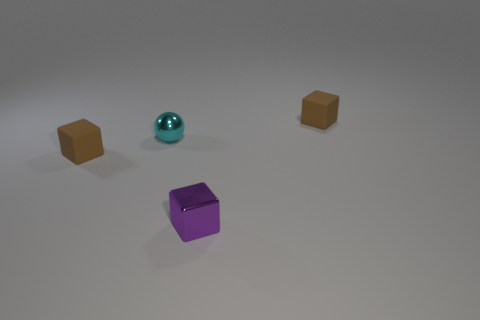There is a brown rubber object to the right of the shiny cube; does it have the same shape as the small purple object?
Offer a terse response. Yes. There is a tiny ball that is made of the same material as the purple cube; what is its color?
Give a very brief answer. Cyan. What material is the brown thing to the right of the cyan metal ball?
Keep it short and to the point. Rubber. There is a small purple shiny object; is its shape the same as the rubber thing that is in front of the tiny cyan ball?
Your answer should be compact. Yes. What is the material of the small cube that is both to the right of the cyan metallic ball and in front of the metal ball?
Offer a terse response. Metal. What is the color of the metallic cube that is the same size as the sphere?
Ensure brevity in your answer.  Purple. Is the tiny purple cube made of the same material as the cyan object that is behind the metallic block?
Offer a very short reply. Yes. What number of other things are the same size as the cyan sphere?
Make the answer very short. 3. Is there a cyan metallic sphere that is on the right side of the small block that is behind the small brown cube that is in front of the tiny ball?
Keep it short and to the point. No. There is a brown block that is right of the cyan shiny sphere; what size is it?
Provide a succinct answer. Small. 